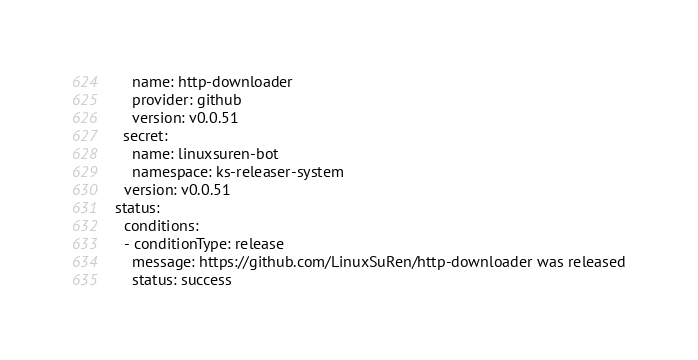Convert code to text. <code><loc_0><loc_0><loc_500><loc_500><_YAML_>    name: http-downloader
    provider: github
    version: v0.0.51
  secret:
    name: linuxsuren-bot
    namespace: ks-releaser-system
  version: v0.0.51
status:
  conditions:
  - conditionType: release
    message: https://github.com/LinuxSuRen/http-downloader was released
    status: success
</code> 